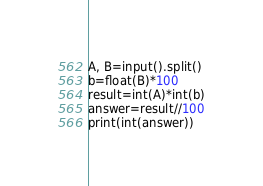<code> <loc_0><loc_0><loc_500><loc_500><_Python_>A, B=input().split()
b=float(B)*100
result=int(A)*int(b)
answer=result//100
print(int(answer))

</code> 